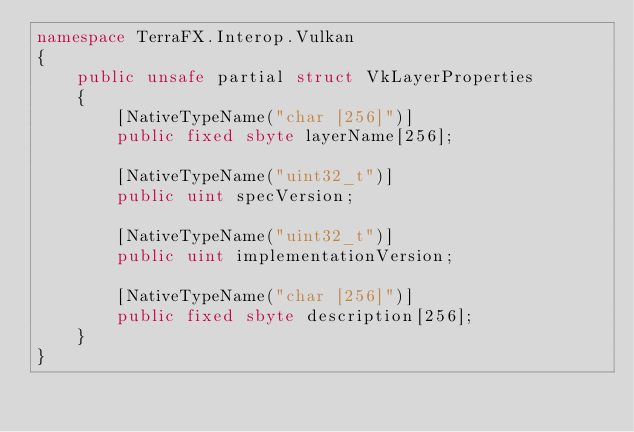<code> <loc_0><loc_0><loc_500><loc_500><_C#_>namespace TerraFX.Interop.Vulkan
{
    public unsafe partial struct VkLayerProperties
    {
        [NativeTypeName("char [256]")]
        public fixed sbyte layerName[256];

        [NativeTypeName("uint32_t")]
        public uint specVersion;

        [NativeTypeName("uint32_t")]
        public uint implementationVersion;

        [NativeTypeName("char [256]")]
        public fixed sbyte description[256];
    }
}
</code> 